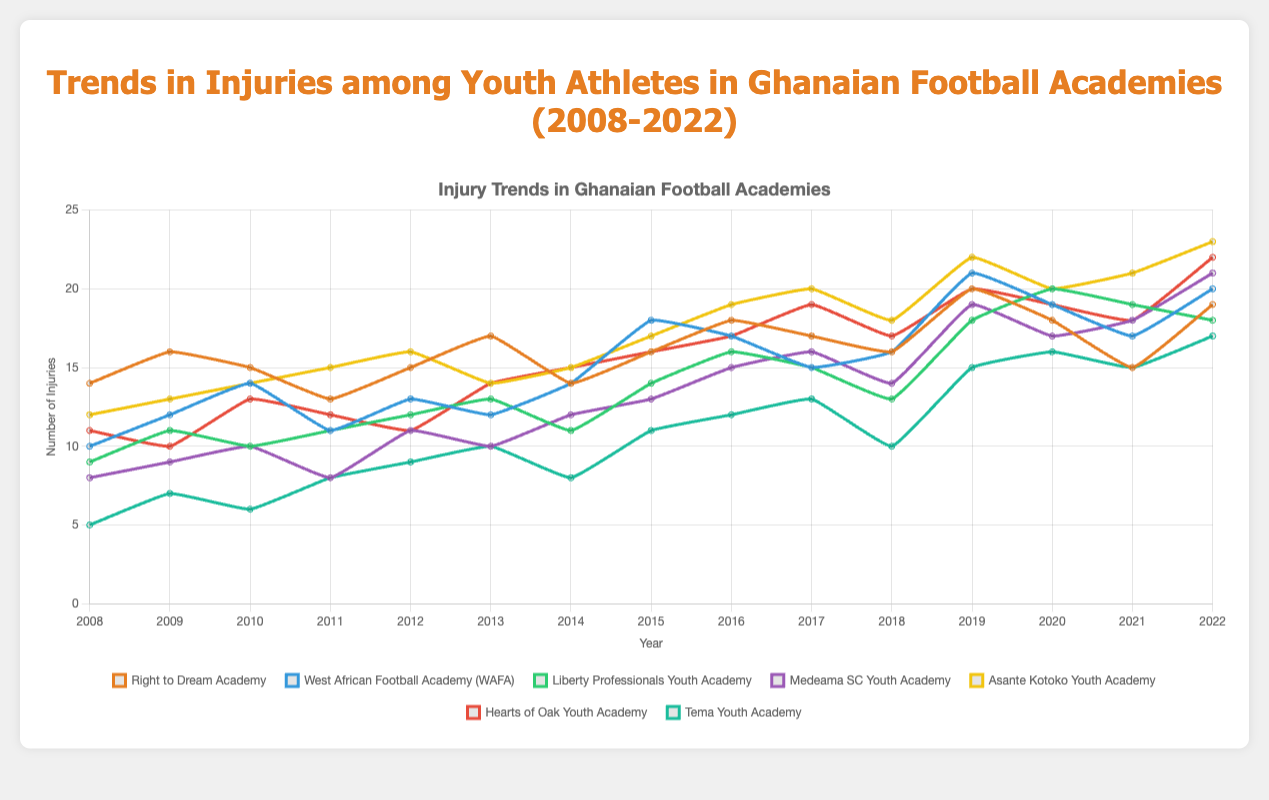How many injuries have occurred at the Asante Kotoko Youth Academy in 2015 and 2022 combined? First, find the number of injuries in 2015 and 2022 for the Asante Kotoko Youth Academy, which are 17 and 23 respectively. Then, add these two numbers together: 17 + 23 = 40
Answer: 40 Which academy had the highest number of injuries in 2020? Compare the number of injuries for each academy in 2020: Right to Dream Academy (18), WAFA (19), Liberty Professionals Youth Academy (20), Medeama SC Youth Academy (17), Asante Kotoko Youth Academy (20), Hearts of Oak Youth Academy (19), and Tema Youth Academy (16). Liberty Professionals Youth Academy and Asante Kotoko Youth Academy have the highest with 20 injuries each
Answer: Liberty Professionals Youth Academy and Asante Kotoko Youth Academy What is the average number of injuries per year for Hearts of Oak Youth Academy? Summing the number of injuries for Hearts of Oak Youth Academy over the 15 years: 11 + 10 + 13 + 12 + 11 + 14 + 15 + 16 + 17 + 19 + 17 + 20 + 19 + 18 + 22 = 234. Then, divide this by 15: 234 / 15 = 15.6
Answer: 15.6 Which academy's injury trend shows the greatest increase from 2018 to 2019? To find the greatest increase, calculate the difference in injuries from 2018 to 2019 for each academy: Right to Dream Academy (4), WAFA (5), Liberty Professionals Youth Academy (5), Medeama SC Youth Academy (5), Asante Kotoko Youth Academy (4), Hearts of Oak Youth Academy (3), and Tema Youth Academy (5). Liberty Professionals Youth Academy, WAFA, Medeama SC Youth Academy, and Tema Youth Academy all have the greatest increase of 5
Answer: WAFA, Liberty Professionals Youth Academy, Medeama SC Youth Academy, Tema Youth Academy Which academy had the lowest number of injuries in the year 2013? Compare the number of injuries for each academy in 2013: Right to Dream Academy (17), WAFA (12), Liberty Professionals Youth Academy (13), Medeama SC Youth Academy (10), Asante Kotoko Youth Academy (14), Hearts of Oak Youth Academy (14), and Tema Youth Academy (10). Medeama SC Youth Academy and Tema Youth Academy have the lowest with 10 injuries each
Answer: Medeama SC Youth Academy and Tema Youth Academy Are there any academies that show a consistent year-over-year increase in injuries? Analyze the injury trends for each academy to see if the number of injuries increases every year:
- Right to Dream Academy: No 
- WAFA: No 
- Liberty Professionals Youth Academy: No 
- Medeama SC Youth Academy: No 
- Asante Kotoko Youth Academy: No 
- Hearts of Oak Youth Academy: No 
- Tema Youth Academy: No
None of the academies show a consistent year-over-year increase
Answer: None What is the difference in the number of injuries between Right to Dream Academy and WAFA in 2022? Find the number of injuries in 2022 for Right to Dream Academy (19) and WAFA (20). Then calculate the difference between them: 20 - 19 = 1
Answer: 1 During which year did Tema Youth Academy experience the highest number of injuries, and how many were reported? Examine the yearly injury data for Tema Youth Academy: the highest number is in 2022 with 17 injuries
Answer: 2022, 17 injuries What is the median number of injuries for Medeama SC Youth Academy over the 15-year period? List the injury numbers for Medeama SC Youth Academy in ascending order: [8, 8, 9, 10, 10, 11, 12, 13, 14, 15, 16, 17, 18, 19, 21]. The median is the middle number in this ordered list, which is 13
Answer: 13 